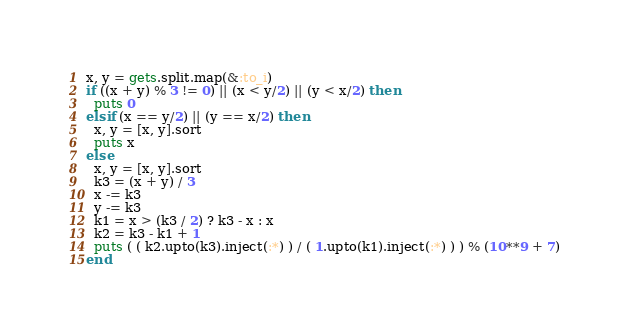<code> <loc_0><loc_0><loc_500><loc_500><_Ruby_>x, y = gets.split.map(&:to_i)
if ((x + y) % 3 != 0) || (x < y/2) || (y < x/2) then
  puts 0
elsif (x == y/2) || (y == x/2) then
  x, y = [x, y].sort
  puts x
else
  x, y = [x, y].sort
  k3 = (x + y) / 3
  x -= k3
  y -= k3
  k1 = x > (k3 / 2) ? k3 - x : x
  k2 = k3 - k1 + 1
  puts ( ( k2.upto(k3).inject(:*) ) / ( 1.upto(k1).inject(:*) ) ) % (10**9 + 7)
end</code> 